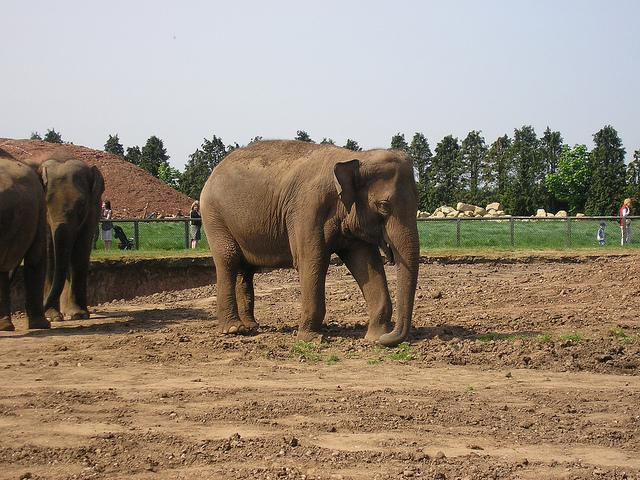Why do people gather outside the fence?

Choices:
A) elephant rides
B) resting
C) waiting bus
D) watch elephants watch elephants 